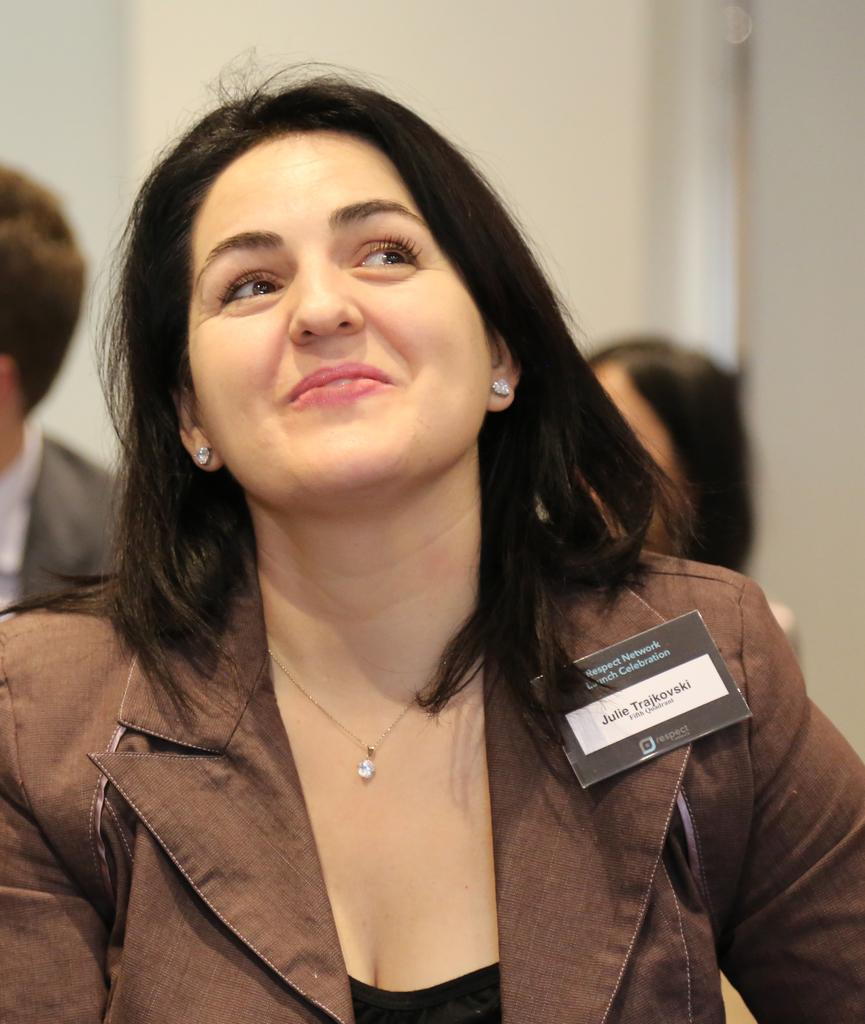Who is present in the image? There is a woman in the image. What is the woman's facial expression? The woman is smiling. Can you describe any accessories the woman is wearing? The woman is wearing a name badge on her sleeves. How many spiders are crawling on the woman's arm in the image? There are no spiders present in the image. What type of dolls can be seen in the background of the image? There are no dolls present in the image. 